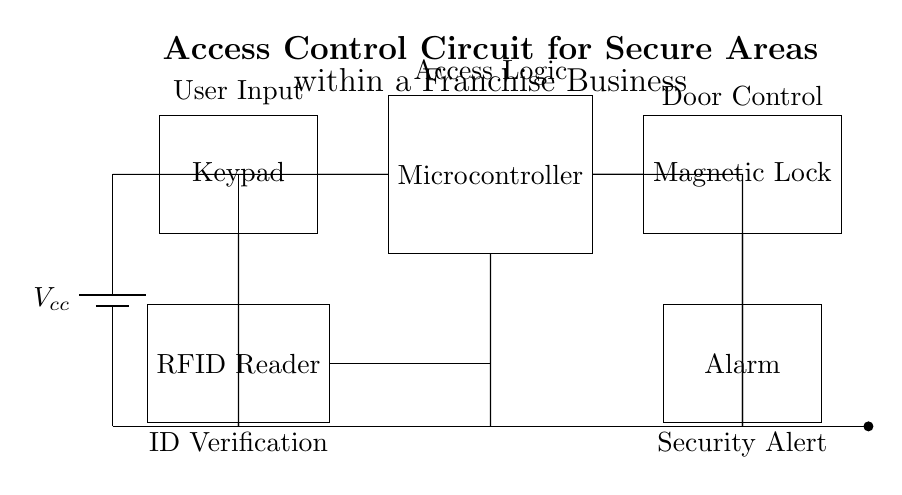What is the power supply in this circuit? The power supply is represented as a battery labeled Vcc, which powers the entire circuit by providing the necessary voltage.
Answer: Vcc What component handles user input? The component that handles user input is the keypad, which is used for entering security codes.
Answer: Keypad How many components are directly connected to the microcontroller? The microcontroller has two direct connections: one from the keypad and one from the RFID reader, indicating its role in processing inputs from both sources.
Answer: Two What is the function of the RFID Reader in the circuit? The RFID Reader is used for ID verification, allowing authorised personnel to gain access by scanning their RFID tags or cards.
Answer: ID Verification What action occurs when the microcontroller processes valid input? When the microcontroller processes valid input, it activates the magnetic lock, allowing the door to unlock for authorized access.
Answer: Unlock What security feature is included in the circuit aside from door control? The circuit includes an alarm, which serves as a security alert to notify personnel of unauthorized access attempts or compromises in security.
Answer: Alarm 